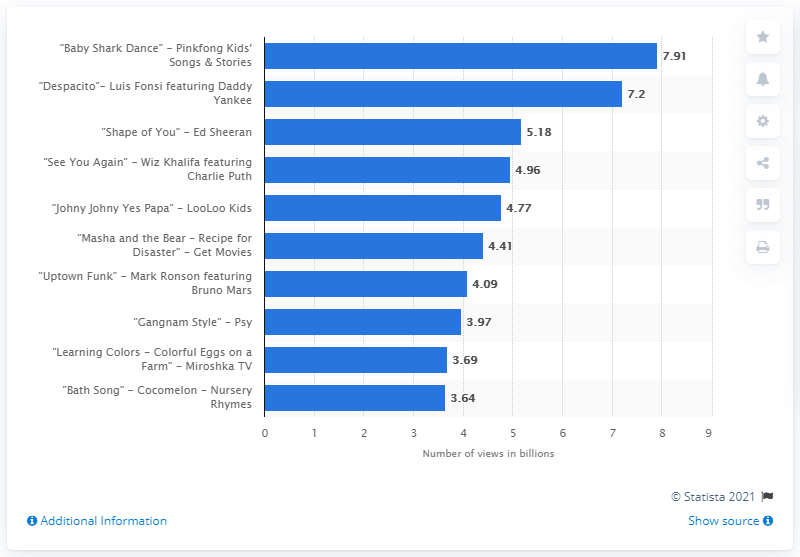Indicate a few pertinent items in this graphic. According to YouTube, "Baby Shark Dance" has accumulated a total of 7,910,000 lifetime views as of now. There is a significant difference in the number of views between the most and least popular YouTube videos. Specifically, the most popular video has 4,270,702 views while the least popular video has 4,270,702 views. The title of the x-axis is "Number of views in billions. 